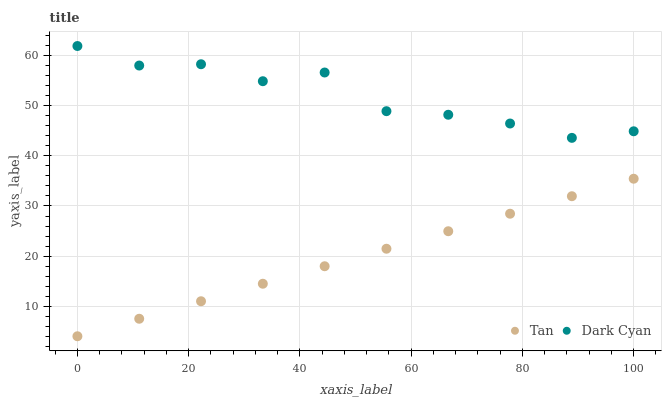Does Tan have the minimum area under the curve?
Answer yes or no. Yes. Does Dark Cyan have the maximum area under the curve?
Answer yes or no. Yes. Does Tan have the maximum area under the curve?
Answer yes or no. No. Is Tan the smoothest?
Answer yes or no. Yes. Is Dark Cyan the roughest?
Answer yes or no. Yes. Is Tan the roughest?
Answer yes or no. No. Does Tan have the lowest value?
Answer yes or no. Yes. Does Dark Cyan have the highest value?
Answer yes or no. Yes. Does Tan have the highest value?
Answer yes or no. No. Is Tan less than Dark Cyan?
Answer yes or no. Yes. Is Dark Cyan greater than Tan?
Answer yes or no. Yes. Does Tan intersect Dark Cyan?
Answer yes or no. No. 